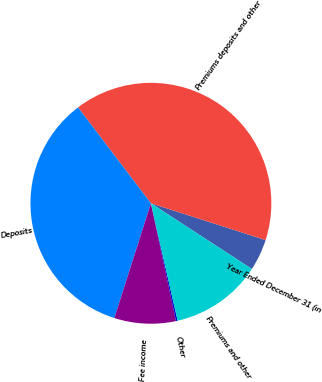<chart> <loc_0><loc_0><loc_500><loc_500><pie_chart><fcel>Year Ended December 31 (in<fcel>Premiums deposits and other<fcel>Deposits<fcel>Fee income<fcel>Other<fcel>Premiums and other<nl><fcel>4.24%<fcel>40.29%<fcel>34.75%<fcel>8.25%<fcel>0.22%<fcel>12.26%<nl></chart> 